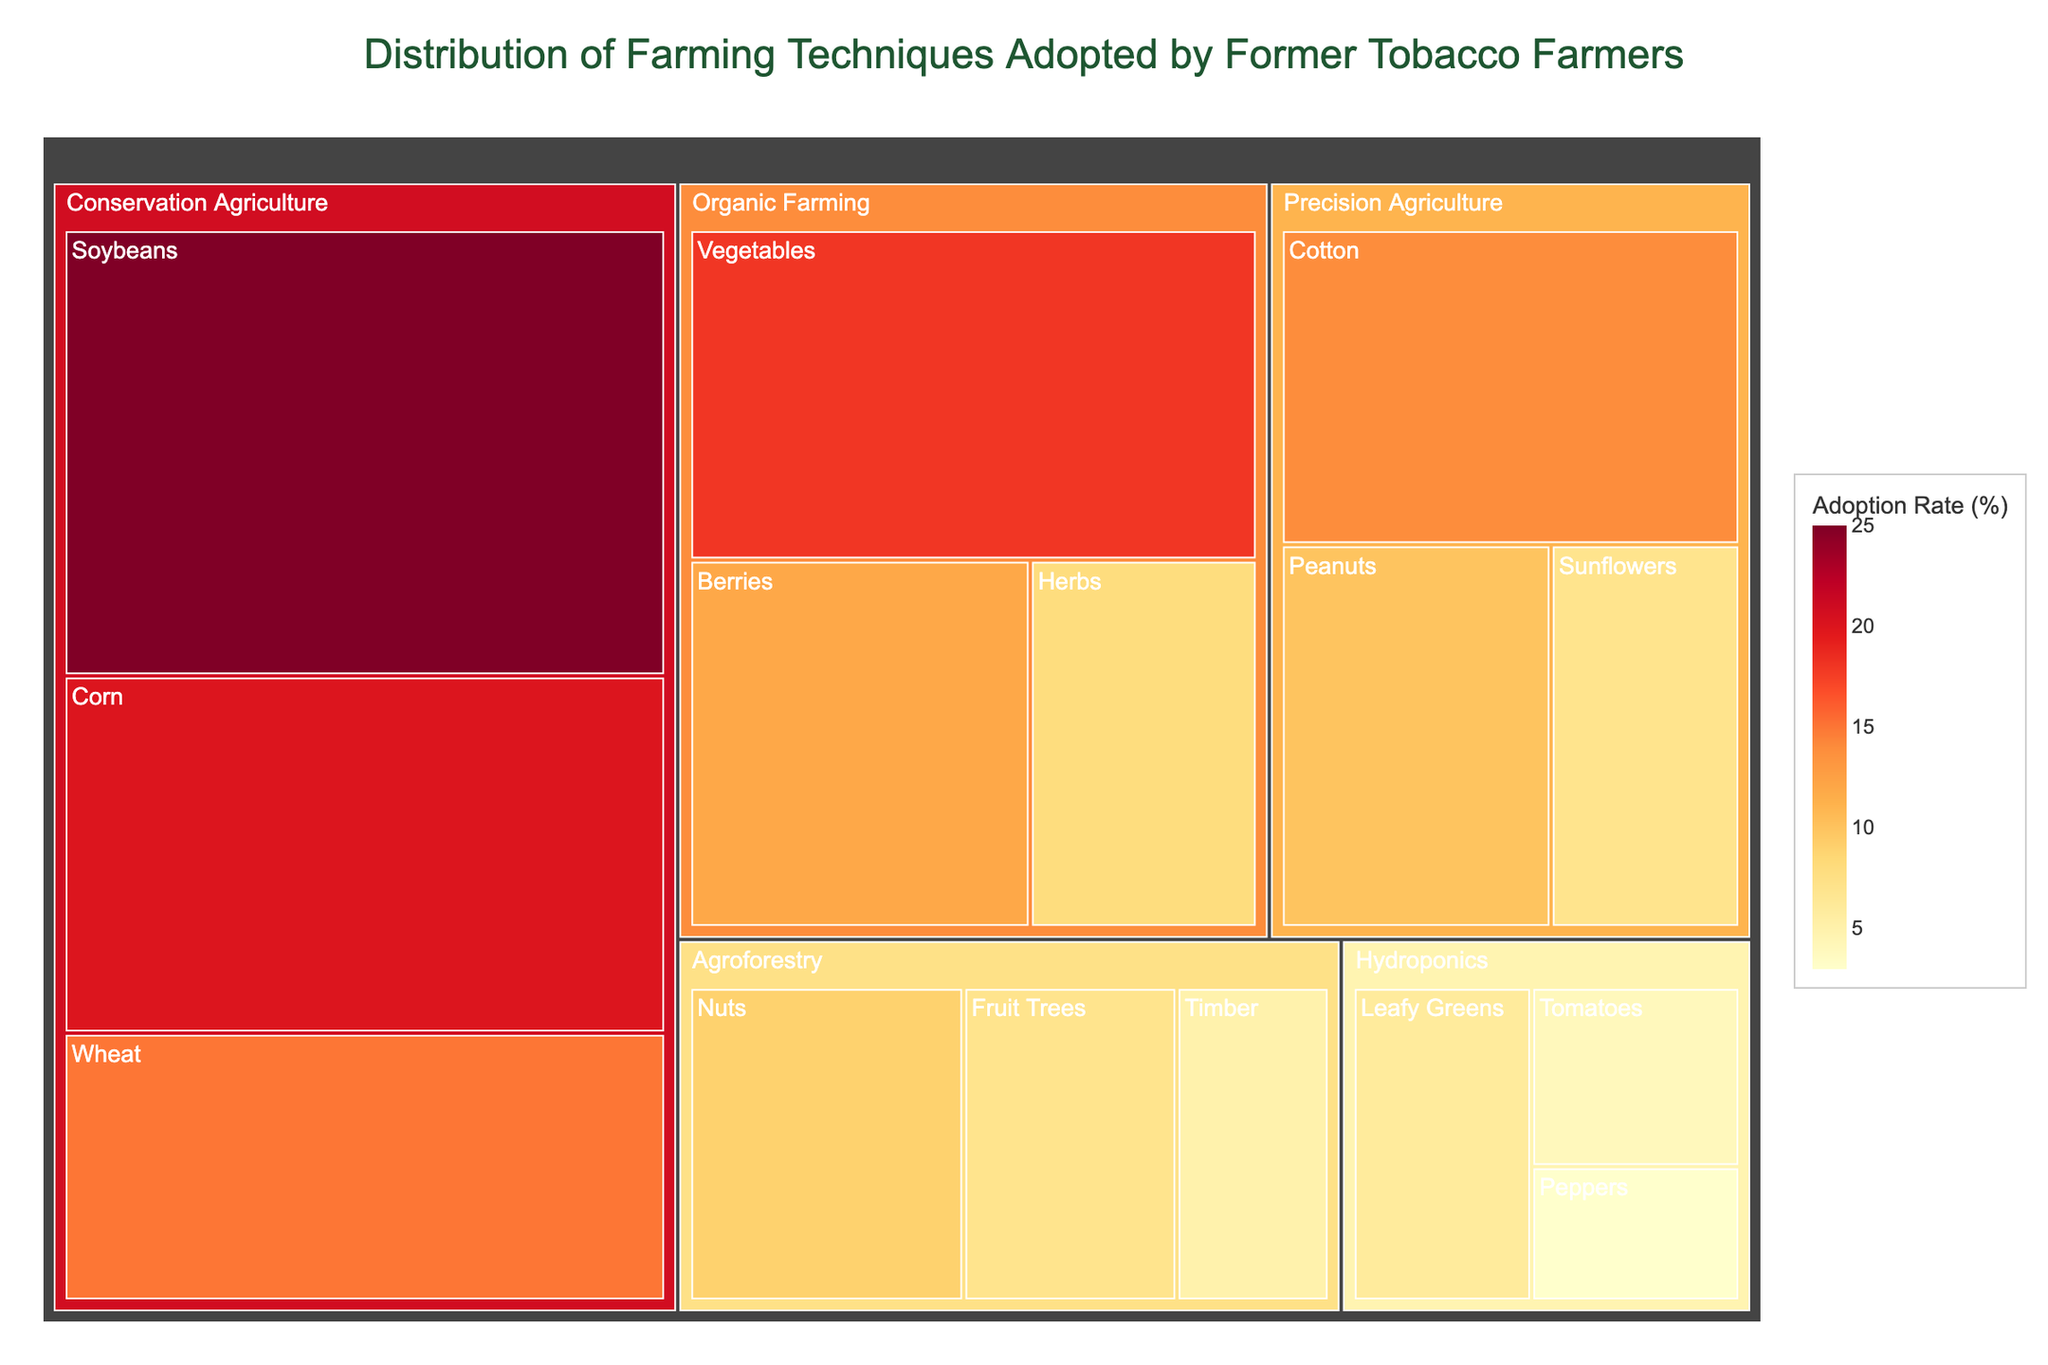what is the title of the treemap? The title is usually located at the top of the treemap. It provides a brief description of what the figure represents.
Answer: Distribution of Farming Techniques Adopted by Former Tobacco Farmers Which farming technique has the highest total adoption rate? Sum the adoption rates of all crops within each farming technique and compare them.
Answer: Conservation Agriculture What is the adoption rate for Organic Farming with Vegetables? Look for the specific tile under Organic Farming labeled Vegetables and note the adoption rate displayed.
Answer: 18% Which crop under Precision Agriculture has the smallest adoption rate? Identify all the crops under Precision Agriculture and compare their adoption rates.
Answer: Sunflowers How much greater is the adoption rate of Soybeans compared to Wheat under Conservation Agriculture? Subtract the adoption rate of Wheat from the adoption rate of Soybeans under Conservation Agriculture.
Answer: 10% Which farming technique is utilized least for growing Peppers? Identify the farming technique linked to Peppers and observe the adoption rate.
Answer: Hydroponics What is the total adoption rate for all crops under Agroforestry? Sum the adoption rates of all crops listed under Agroforestry.
Answer: 21% Among all crops, which has the highest adoption rate? Compare the adoption rates of all individual crops and find the highest value.
Answer: Soybeans What is the overall trend in adoption rates for crops grown using Hydroponics? Observe the color gradients for all Hydroponics crops, indicating the adoption rates.
Answer: Generally low Which farming technique has an equal adoption rate of 25%? Identify the farming technique with the precise adoption rate specified and check if it matches one provided in the data.
Answer: Conservation Agriculture 